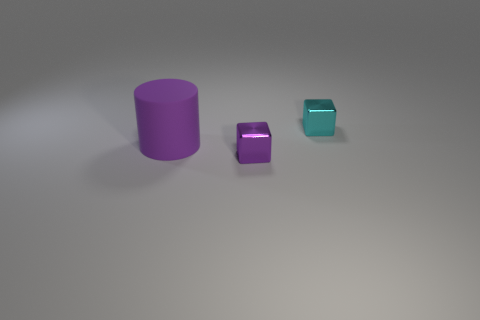What could be the possible use of these objects in a real-world setting? These objects could be used for various educational purposes, such as teaching geometry or material properties in a classroom setting. 